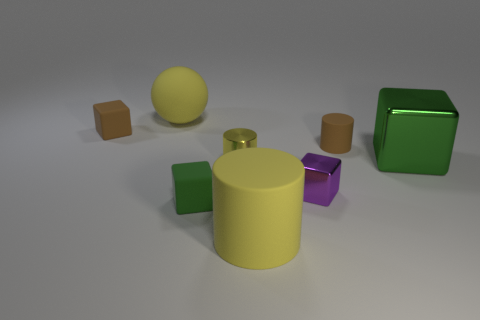Subtract all tiny brown rubber cubes. How many cubes are left? 3 Add 1 metallic cylinders. How many objects exist? 9 Subtract all purple cylinders. How many green cubes are left? 2 Subtract 3 cubes. How many cubes are left? 1 Subtract all cylinders. How many objects are left? 5 Subtract all brown cylinders. How many cylinders are left? 2 Add 4 blocks. How many blocks exist? 8 Subtract 0 green balls. How many objects are left? 8 Subtract all green balls. Subtract all blue blocks. How many balls are left? 1 Subtract all big brown shiny balls. Subtract all big green cubes. How many objects are left? 7 